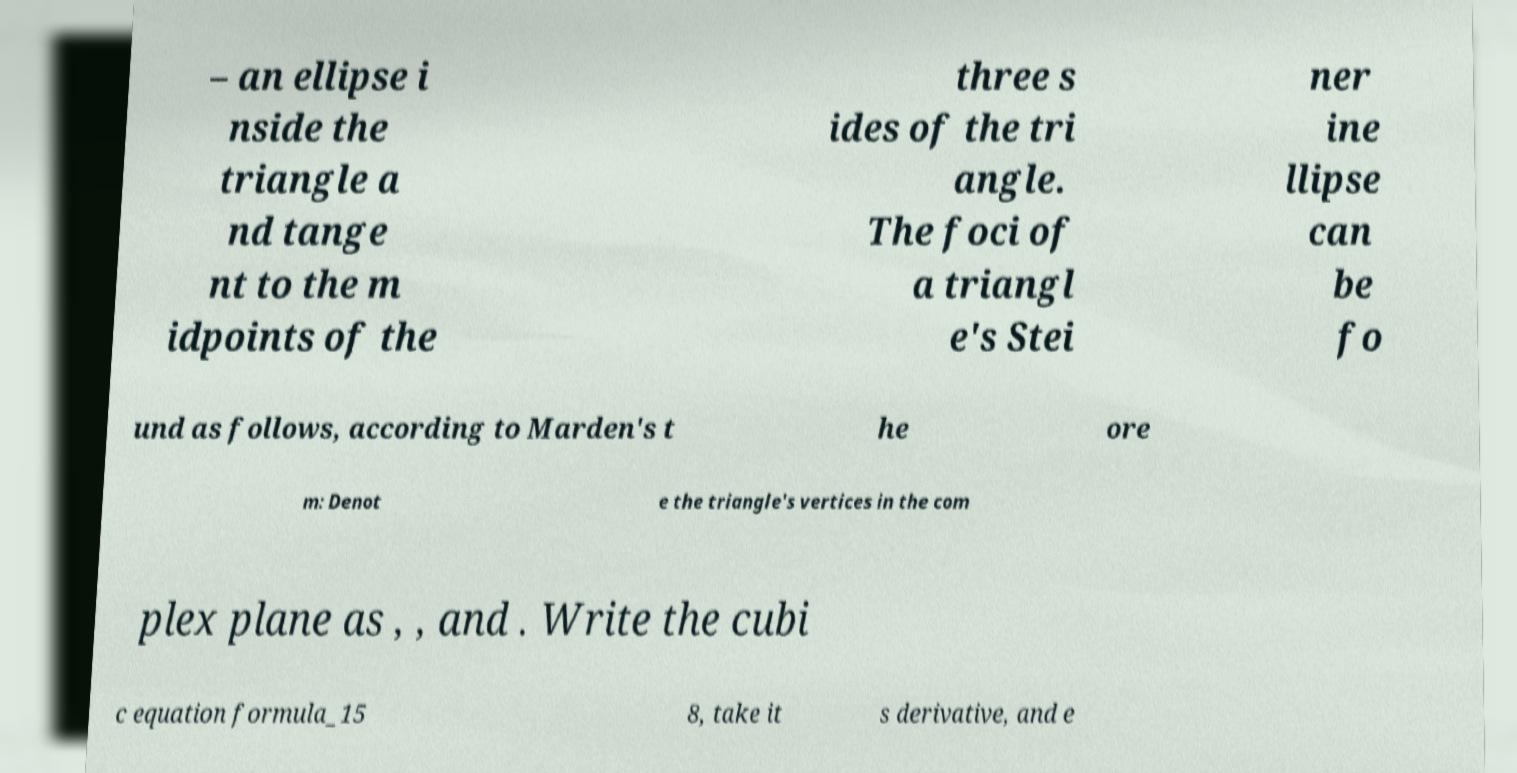What messages or text are displayed in this image? I need them in a readable, typed format. – an ellipse i nside the triangle a nd tange nt to the m idpoints of the three s ides of the tri angle. The foci of a triangl e's Stei ner ine llipse can be fo und as follows, according to Marden's t he ore m: Denot e the triangle's vertices in the com plex plane as , , and . Write the cubi c equation formula_15 8, take it s derivative, and e 